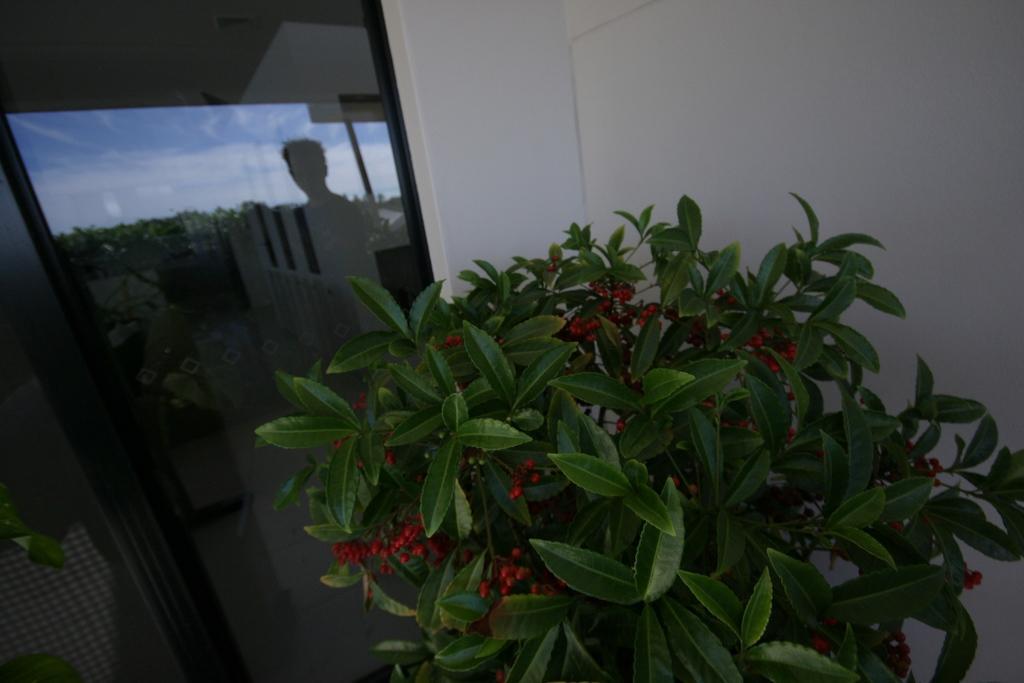How would you summarize this image in a sentence or two? In this image we can see a plant, trees, there is a reflection of a person on the window, also we can see the wall, and the sky. 